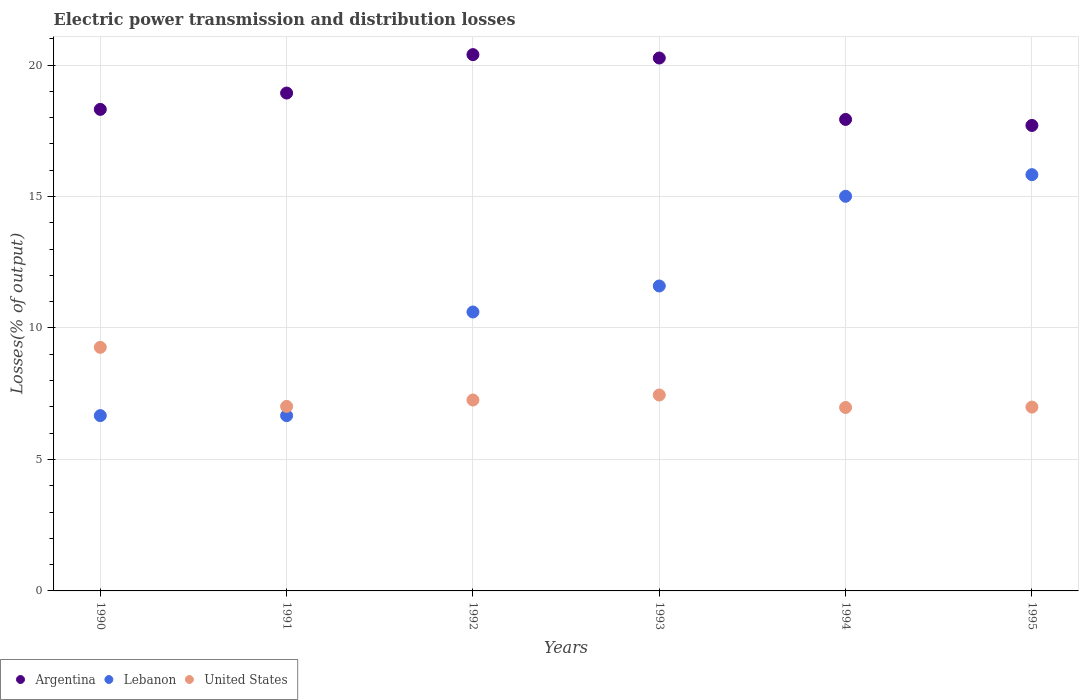How many different coloured dotlines are there?
Your response must be concise. 3. What is the electric power transmission and distribution losses in United States in 1994?
Provide a succinct answer. 6.98. Across all years, what is the maximum electric power transmission and distribution losses in Lebanon?
Give a very brief answer. 15.83. Across all years, what is the minimum electric power transmission and distribution losses in United States?
Provide a short and direct response. 6.98. In which year was the electric power transmission and distribution losses in Argentina maximum?
Provide a succinct answer. 1992. What is the total electric power transmission and distribution losses in Argentina in the graph?
Offer a very short reply. 113.54. What is the difference between the electric power transmission and distribution losses in Lebanon in 1993 and that in 1994?
Your response must be concise. -3.41. What is the difference between the electric power transmission and distribution losses in Argentina in 1992 and the electric power transmission and distribution losses in Lebanon in 1995?
Keep it short and to the point. 4.56. What is the average electric power transmission and distribution losses in Lebanon per year?
Offer a very short reply. 11.06. In the year 1995, what is the difference between the electric power transmission and distribution losses in United States and electric power transmission and distribution losses in Argentina?
Keep it short and to the point. -10.71. In how many years, is the electric power transmission and distribution losses in Argentina greater than 1 %?
Make the answer very short. 6. What is the ratio of the electric power transmission and distribution losses in Lebanon in 1992 to that in 1995?
Your answer should be very brief. 0.67. Is the electric power transmission and distribution losses in Lebanon in 1992 less than that in 1995?
Provide a short and direct response. Yes. What is the difference between the highest and the second highest electric power transmission and distribution losses in United States?
Your response must be concise. 1.81. What is the difference between the highest and the lowest electric power transmission and distribution losses in Lebanon?
Give a very brief answer. 9.16. In how many years, is the electric power transmission and distribution losses in United States greater than the average electric power transmission and distribution losses in United States taken over all years?
Provide a succinct answer. 1. Is the electric power transmission and distribution losses in United States strictly less than the electric power transmission and distribution losses in Lebanon over the years?
Give a very brief answer. No. How many years are there in the graph?
Make the answer very short. 6. Does the graph contain any zero values?
Give a very brief answer. No. Where does the legend appear in the graph?
Ensure brevity in your answer.  Bottom left. How many legend labels are there?
Provide a short and direct response. 3. How are the legend labels stacked?
Your response must be concise. Horizontal. What is the title of the graph?
Your answer should be compact. Electric power transmission and distribution losses. What is the label or title of the Y-axis?
Offer a terse response. Losses(% of output). What is the Losses(% of output) of Argentina in 1990?
Keep it short and to the point. 18.31. What is the Losses(% of output) in Lebanon in 1990?
Provide a short and direct response. 6.67. What is the Losses(% of output) in United States in 1990?
Your answer should be compact. 9.26. What is the Losses(% of output) of Argentina in 1991?
Ensure brevity in your answer.  18.93. What is the Losses(% of output) of Lebanon in 1991?
Provide a succinct answer. 6.67. What is the Losses(% of output) in United States in 1991?
Ensure brevity in your answer.  7.02. What is the Losses(% of output) in Argentina in 1992?
Your response must be concise. 20.4. What is the Losses(% of output) of Lebanon in 1992?
Ensure brevity in your answer.  10.61. What is the Losses(% of output) in United States in 1992?
Offer a terse response. 7.26. What is the Losses(% of output) of Argentina in 1993?
Your answer should be compact. 20.27. What is the Losses(% of output) of Lebanon in 1993?
Offer a terse response. 11.6. What is the Losses(% of output) in United States in 1993?
Provide a short and direct response. 7.45. What is the Losses(% of output) in Argentina in 1994?
Ensure brevity in your answer.  17.93. What is the Losses(% of output) in Lebanon in 1994?
Make the answer very short. 15.01. What is the Losses(% of output) of United States in 1994?
Your response must be concise. 6.98. What is the Losses(% of output) of Argentina in 1995?
Offer a very short reply. 17.7. What is the Losses(% of output) of Lebanon in 1995?
Your answer should be compact. 15.83. What is the Losses(% of output) in United States in 1995?
Your response must be concise. 6.99. Across all years, what is the maximum Losses(% of output) of Argentina?
Give a very brief answer. 20.4. Across all years, what is the maximum Losses(% of output) of Lebanon?
Keep it short and to the point. 15.83. Across all years, what is the maximum Losses(% of output) of United States?
Your response must be concise. 9.26. Across all years, what is the minimum Losses(% of output) in Argentina?
Your answer should be compact. 17.7. Across all years, what is the minimum Losses(% of output) in Lebanon?
Your answer should be very brief. 6.67. Across all years, what is the minimum Losses(% of output) of United States?
Provide a short and direct response. 6.98. What is the total Losses(% of output) in Argentina in the graph?
Provide a succinct answer. 113.54. What is the total Losses(% of output) of Lebanon in the graph?
Your response must be concise. 66.38. What is the total Losses(% of output) in United States in the graph?
Your answer should be compact. 44.96. What is the difference between the Losses(% of output) of Argentina in 1990 and that in 1991?
Provide a short and direct response. -0.62. What is the difference between the Losses(% of output) in Lebanon in 1990 and that in 1991?
Provide a succinct answer. 0. What is the difference between the Losses(% of output) in United States in 1990 and that in 1991?
Your answer should be very brief. 2.25. What is the difference between the Losses(% of output) in Argentina in 1990 and that in 1992?
Offer a very short reply. -2.08. What is the difference between the Losses(% of output) in Lebanon in 1990 and that in 1992?
Provide a short and direct response. -3.94. What is the difference between the Losses(% of output) of United States in 1990 and that in 1992?
Keep it short and to the point. 2. What is the difference between the Losses(% of output) of Argentina in 1990 and that in 1993?
Offer a very short reply. -1.95. What is the difference between the Losses(% of output) of Lebanon in 1990 and that in 1993?
Your answer should be compact. -4.93. What is the difference between the Losses(% of output) in United States in 1990 and that in 1993?
Your answer should be compact. 1.81. What is the difference between the Losses(% of output) of Argentina in 1990 and that in 1994?
Ensure brevity in your answer.  0.38. What is the difference between the Losses(% of output) in Lebanon in 1990 and that in 1994?
Offer a terse response. -8.34. What is the difference between the Losses(% of output) of United States in 1990 and that in 1994?
Ensure brevity in your answer.  2.29. What is the difference between the Losses(% of output) in Argentina in 1990 and that in 1995?
Provide a succinct answer. 0.61. What is the difference between the Losses(% of output) of Lebanon in 1990 and that in 1995?
Make the answer very short. -9.16. What is the difference between the Losses(% of output) of United States in 1990 and that in 1995?
Offer a terse response. 2.27. What is the difference between the Losses(% of output) of Argentina in 1991 and that in 1992?
Ensure brevity in your answer.  -1.46. What is the difference between the Losses(% of output) in Lebanon in 1991 and that in 1992?
Keep it short and to the point. -3.94. What is the difference between the Losses(% of output) in United States in 1991 and that in 1992?
Give a very brief answer. -0.24. What is the difference between the Losses(% of output) of Argentina in 1991 and that in 1993?
Give a very brief answer. -1.33. What is the difference between the Losses(% of output) in Lebanon in 1991 and that in 1993?
Your answer should be compact. -4.93. What is the difference between the Losses(% of output) of United States in 1991 and that in 1993?
Give a very brief answer. -0.43. What is the difference between the Losses(% of output) of Lebanon in 1991 and that in 1994?
Make the answer very short. -8.34. What is the difference between the Losses(% of output) in United States in 1991 and that in 1994?
Your answer should be compact. 0.04. What is the difference between the Losses(% of output) in Argentina in 1991 and that in 1995?
Ensure brevity in your answer.  1.23. What is the difference between the Losses(% of output) of Lebanon in 1991 and that in 1995?
Offer a terse response. -9.16. What is the difference between the Losses(% of output) in United States in 1991 and that in 1995?
Offer a terse response. 0.03. What is the difference between the Losses(% of output) of Argentina in 1992 and that in 1993?
Your answer should be compact. 0.13. What is the difference between the Losses(% of output) of Lebanon in 1992 and that in 1993?
Make the answer very short. -0.99. What is the difference between the Losses(% of output) in United States in 1992 and that in 1993?
Ensure brevity in your answer.  -0.19. What is the difference between the Losses(% of output) in Argentina in 1992 and that in 1994?
Offer a very short reply. 2.46. What is the difference between the Losses(% of output) of Lebanon in 1992 and that in 1994?
Your answer should be very brief. -4.4. What is the difference between the Losses(% of output) of United States in 1992 and that in 1994?
Provide a succinct answer. 0.28. What is the difference between the Losses(% of output) of Argentina in 1992 and that in 1995?
Your response must be concise. 2.69. What is the difference between the Losses(% of output) in Lebanon in 1992 and that in 1995?
Provide a short and direct response. -5.22. What is the difference between the Losses(% of output) of United States in 1992 and that in 1995?
Your answer should be compact. 0.27. What is the difference between the Losses(% of output) in Argentina in 1993 and that in 1994?
Give a very brief answer. 2.34. What is the difference between the Losses(% of output) in Lebanon in 1993 and that in 1994?
Keep it short and to the point. -3.41. What is the difference between the Losses(% of output) in United States in 1993 and that in 1994?
Ensure brevity in your answer.  0.48. What is the difference between the Losses(% of output) of Argentina in 1993 and that in 1995?
Offer a very short reply. 2.56. What is the difference between the Losses(% of output) in Lebanon in 1993 and that in 1995?
Offer a terse response. -4.23. What is the difference between the Losses(% of output) of United States in 1993 and that in 1995?
Your answer should be very brief. 0.46. What is the difference between the Losses(% of output) of Argentina in 1994 and that in 1995?
Provide a short and direct response. 0.23. What is the difference between the Losses(% of output) of Lebanon in 1994 and that in 1995?
Your answer should be compact. -0.82. What is the difference between the Losses(% of output) in United States in 1994 and that in 1995?
Give a very brief answer. -0.01. What is the difference between the Losses(% of output) in Argentina in 1990 and the Losses(% of output) in Lebanon in 1991?
Ensure brevity in your answer.  11.65. What is the difference between the Losses(% of output) in Argentina in 1990 and the Losses(% of output) in United States in 1991?
Provide a succinct answer. 11.3. What is the difference between the Losses(% of output) of Lebanon in 1990 and the Losses(% of output) of United States in 1991?
Give a very brief answer. -0.35. What is the difference between the Losses(% of output) of Argentina in 1990 and the Losses(% of output) of Lebanon in 1992?
Make the answer very short. 7.71. What is the difference between the Losses(% of output) in Argentina in 1990 and the Losses(% of output) in United States in 1992?
Provide a short and direct response. 11.05. What is the difference between the Losses(% of output) of Lebanon in 1990 and the Losses(% of output) of United States in 1992?
Make the answer very short. -0.59. What is the difference between the Losses(% of output) of Argentina in 1990 and the Losses(% of output) of Lebanon in 1993?
Provide a short and direct response. 6.72. What is the difference between the Losses(% of output) in Argentina in 1990 and the Losses(% of output) in United States in 1993?
Your answer should be compact. 10.86. What is the difference between the Losses(% of output) in Lebanon in 1990 and the Losses(% of output) in United States in 1993?
Your answer should be compact. -0.78. What is the difference between the Losses(% of output) of Argentina in 1990 and the Losses(% of output) of Lebanon in 1994?
Your answer should be compact. 3.31. What is the difference between the Losses(% of output) of Argentina in 1990 and the Losses(% of output) of United States in 1994?
Provide a succinct answer. 11.34. What is the difference between the Losses(% of output) of Lebanon in 1990 and the Losses(% of output) of United States in 1994?
Your response must be concise. -0.31. What is the difference between the Losses(% of output) of Argentina in 1990 and the Losses(% of output) of Lebanon in 1995?
Your response must be concise. 2.48. What is the difference between the Losses(% of output) in Argentina in 1990 and the Losses(% of output) in United States in 1995?
Your answer should be very brief. 11.32. What is the difference between the Losses(% of output) of Lebanon in 1990 and the Losses(% of output) of United States in 1995?
Make the answer very short. -0.32. What is the difference between the Losses(% of output) of Argentina in 1991 and the Losses(% of output) of Lebanon in 1992?
Provide a short and direct response. 8.33. What is the difference between the Losses(% of output) in Argentina in 1991 and the Losses(% of output) in United States in 1992?
Your response must be concise. 11.67. What is the difference between the Losses(% of output) of Lebanon in 1991 and the Losses(% of output) of United States in 1992?
Your answer should be very brief. -0.59. What is the difference between the Losses(% of output) in Argentina in 1991 and the Losses(% of output) in Lebanon in 1993?
Make the answer very short. 7.34. What is the difference between the Losses(% of output) of Argentina in 1991 and the Losses(% of output) of United States in 1993?
Keep it short and to the point. 11.48. What is the difference between the Losses(% of output) of Lebanon in 1991 and the Losses(% of output) of United States in 1993?
Keep it short and to the point. -0.78. What is the difference between the Losses(% of output) of Argentina in 1991 and the Losses(% of output) of Lebanon in 1994?
Ensure brevity in your answer.  3.93. What is the difference between the Losses(% of output) of Argentina in 1991 and the Losses(% of output) of United States in 1994?
Ensure brevity in your answer.  11.96. What is the difference between the Losses(% of output) of Lebanon in 1991 and the Losses(% of output) of United States in 1994?
Offer a very short reply. -0.31. What is the difference between the Losses(% of output) of Argentina in 1991 and the Losses(% of output) of Lebanon in 1995?
Provide a short and direct response. 3.1. What is the difference between the Losses(% of output) in Argentina in 1991 and the Losses(% of output) in United States in 1995?
Your response must be concise. 11.94. What is the difference between the Losses(% of output) of Lebanon in 1991 and the Losses(% of output) of United States in 1995?
Ensure brevity in your answer.  -0.32. What is the difference between the Losses(% of output) of Argentina in 1992 and the Losses(% of output) of Lebanon in 1993?
Keep it short and to the point. 8.8. What is the difference between the Losses(% of output) of Argentina in 1992 and the Losses(% of output) of United States in 1993?
Keep it short and to the point. 12.94. What is the difference between the Losses(% of output) of Lebanon in 1992 and the Losses(% of output) of United States in 1993?
Your answer should be compact. 3.16. What is the difference between the Losses(% of output) in Argentina in 1992 and the Losses(% of output) in Lebanon in 1994?
Provide a short and direct response. 5.39. What is the difference between the Losses(% of output) in Argentina in 1992 and the Losses(% of output) in United States in 1994?
Your response must be concise. 13.42. What is the difference between the Losses(% of output) of Lebanon in 1992 and the Losses(% of output) of United States in 1994?
Your response must be concise. 3.63. What is the difference between the Losses(% of output) of Argentina in 1992 and the Losses(% of output) of Lebanon in 1995?
Make the answer very short. 4.56. What is the difference between the Losses(% of output) in Argentina in 1992 and the Losses(% of output) in United States in 1995?
Provide a succinct answer. 13.4. What is the difference between the Losses(% of output) in Lebanon in 1992 and the Losses(% of output) in United States in 1995?
Offer a terse response. 3.62. What is the difference between the Losses(% of output) of Argentina in 1993 and the Losses(% of output) of Lebanon in 1994?
Make the answer very short. 5.26. What is the difference between the Losses(% of output) of Argentina in 1993 and the Losses(% of output) of United States in 1994?
Your answer should be compact. 13.29. What is the difference between the Losses(% of output) of Lebanon in 1993 and the Losses(% of output) of United States in 1994?
Provide a succinct answer. 4.62. What is the difference between the Losses(% of output) of Argentina in 1993 and the Losses(% of output) of Lebanon in 1995?
Offer a terse response. 4.44. What is the difference between the Losses(% of output) of Argentina in 1993 and the Losses(% of output) of United States in 1995?
Offer a very short reply. 13.28. What is the difference between the Losses(% of output) in Lebanon in 1993 and the Losses(% of output) in United States in 1995?
Keep it short and to the point. 4.61. What is the difference between the Losses(% of output) in Argentina in 1994 and the Losses(% of output) in Lebanon in 1995?
Your answer should be very brief. 2.1. What is the difference between the Losses(% of output) of Argentina in 1994 and the Losses(% of output) of United States in 1995?
Provide a short and direct response. 10.94. What is the difference between the Losses(% of output) of Lebanon in 1994 and the Losses(% of output) of United States in 1995?
Offer a terse response. 8.02. What is the average Losses(% of output) in Argentina per year?
Your answer should be compact. 18.92. What is the average Losses(% of output) of Lebanon per year?
Make the answer very short. 11.06. What is the average Losses(% of output) in United States per year?
Ensure brevity in your answer.  7.49. In the year 1990, what is the difference between the Losses(% of output) of Argentina and Losses(% of output) of Lebanon?
Your answer should be compact. 11.65. In the year 1990, what is the difference between the Losses(% of output) in Argentina and Losses(% of output) in United States?
Your answer should be very brief. 9.05. In the year 1990, what is the difference between the Losses(% of output) of Lebanon and Losses(% of output) of United States?
Offer a terse response. -2.6. In the year 1991, what is the difference between the Losses(% of output) in Argentina and Losses(% of output) in Lebanon?
Make the answer very short. 12.27. In the year 1991, what is the difference between the Losses(% of output) of Argentina and Losses(% of output) of United States?
Provide a succinct answer. 11.92. In the year 1991, what is the difference between the Losses(% of output) in Lebanon and Losses(% of output) in United States?
Make the answer very short. -0.35. In the year 1992, what is the difference between the Losses(% of output) of Argentina and Losses(% of output) of Lebanon?
Provide a succinct answer. 9.79. In the year 1992, what is the difference between the Losses(% of output) in Argentina and Losses(% of output) in United States?
Make the answer very short. 13.13. In the year 1992, what is the difference between the Losses(% of output) in Lebanon and Losses(% of output) in United States?
Provide a succinct answer. 3.35. In the year 1993, what is the difference between the Losses(% of output) in Argentina and Losses(% of output) in Lebanon?
Offer a very short reply. 8.67. In the year 1993, what is the difference between the Losses(% of output) of Argentina and Losses(% of output) of United States?
Provide a succinct answer. 12.81. In the year 1993, what is the difference between the Losses(% of output) of Lebanon and Losses(% of output) of United States?
Offer a very short reply. 4.15. In the year 1994, what is the difference between the Losses(% of output) of Argentina and Losses(% of output) of Lebanon?
Offer a very short reply. 2.92. In the year 1994, what is the difference between the Losses(% of output) in Argentina and Losses(% of output) in United States?
Ensure brevity in your answer.  10.95. In the year 1994, what is the difference between the Losses(% of output) of Lebanon and Losses(% of output) of United States?
Your answer should be compact. 8.03. In the year 1995, what is the difference between the Losses(% of output) in Argentina and Losses(% of output) in Lebanon?
Make the answer very short. 1.87. In the year 1995, what is the difference between the Losses(% of output) of Argentina and Losses(% of output) of United States?
Make the answer very short. 10.71. In the year 1995, what is the difference between the Losses(% of output) in Lebanon and Losses(% of output) in United States?
Offer a terse response. 8.84. What is the ratio of the Losses(% of output) of Argentina in 1990 to that in 1991?
Offer a very short reply. 0.97. What is the ratio of the Losses(% of output) of Lebanon in 1990 to that in 1991?
Provide a succinct answer. 1. What is the ratio of the Losses(% of output) of United States in 1990 to that in 1991?
Ensure brevity in your answer.  1.32. What is the ratio of the Losses(% of output) of Argentina in 1990 to that in 1992?
Ensure brevity in your answer.  0.9. What is the ratio of the Losses(% of output) in Lebanon in 1990 to that in 1992?
Offer a terse response. 0.63. What is the ratio of the Losses(% of output) in United States in 1990 to that in 1992?
Your answer should be very brief. 1.28. What is the ratio of the Losses(% of output) in Argentina in 1990 to that in 1993?
Offer a terse response. 0.9. What is the ratio of the Losses(% of output) of Lebanon in 1990 to that in 1993?
Offer a very short reply. 0.57. What is the ratio of the Losses(% of output) in United States in 1990 to that in 1993?
Make the answer very short. 1.24. What is the ratio of the Losses(% of output) of Argentina in 1990 to that in 1994?
Offer a terse response. 1.02. What is the ratio of the Losses(% of output) of Lebanon in 1990 to that in 1994?
Provide a short and direct response. 0.44. What is the ratio of the Losses(% of output) in United States in 1990 to that in 1994?
Provide a succinct answer. 1.33. What is the ratio of the Losses(% of output) of Argentina in 1990 to that in 1995?
Give a very brief answer. 1.03. What is the ratio of the Losses(% of output) in Lebanon in 1990 to that in 1995?
Provide a short and direct response. 0.42. What is the ratio of the Losses(% of output) of United States in 1990 to that in 1995?
Keep it short and to the point. 1.33. What is the ratio of the Losses(% of output) in Argentina in 1991 to that in 1992?
Make the answer very short. 0.93. What is the ratio of the Losses(% of output) of Lebanon in 1991 to that in 1992?
Provide a succinct answer. 0.63. What is the ratio of the Losses(% of output) of United States in 1991 to that in 1992?
Give a very brief answer. 0.97. What is the ratio of the Losses(% of output) of Argentina in 1991 to that in 1993?
Your response must be concise. 0.93. What is the ratio of the Losses(% of output) in Lebanon in 1991 to that in 1993?
Offer a terse response. 0.57. What is the ratio of the Losses(% of output) of United States in 1991 to that in 1993?
Provide a succinct answer. 0.94. What is the ratio of the Losses(% of output) in Argentina in 1991 to that in 1994?
Offer a terse response. 1.06. What is the ratio of the Losses(% of output) in Lebanon in 1991 to that in 1994?
Your answer should be compact. 0.44. What is the ratio of the Losses(% of output) in United States in 1991 to that in 1994?
Give a very brief answer. 1.01. What is the ratio of the Losses(% of output) of Argentina in 1991 to that in 1995?
Keep it short and to the point. 1.07. What is the ratio of the Losses(% of output) in Lebanon in 1991 to that in 1995?
Provide a succinct answer. 0.42. What is the ratio of the Losses(% of output) of Argentina in 1992 to that in 1993?
Your answer should be very brief. 1.01. What is the ratio of the Losses(% of output) in Lebanon in 1992 to that in 1993?
Ensure brevity in your answer.  0.91. What is the ratio of the Losses(% of output) of United States in 1992 to that in 1993?
Offer a very short reply. 0.97. What is the ratio of the Losses(% of output) of Argentina in 1992 to that in 1994?
Provide a short and direct response. 1.14. What is the ratio of the Losses(% of output) of Lebanon in 1992 to that in 1994?
Keep it short and to the point. 0.71. What is the ratio of the Losses(% of output) of United States in 1992 to that in 1994?
Offer a terse response. 1.04. What is the ratio of the Losses(% of output) in Argentina in 1992 to that in 1995?
Your answer should be compact. 1.15. What is the ratio of the Losses(% of output) in Lebanon in 1992 to that in 1995?
Keep it short and to the point. 0.67. What is the ratio of the Losses(% of output) in United States in 1992 to that in 1995?
Your answer should be compact. 1.04. What is the ratio of the Losses(% of output) in Argentina in 1993 to that in 1994?
Provide a short and direct response. 1.13. What is the ratio of the Losses(% of output) in Lebanon in 1993 to that in 1994?
Your answer should be compact. 0.77. What is the ratio of the Losses(% of output) in United States in 1993 to that in 1994?
Your answer should be compact. 1.07. What is the ratio of the Losses(% of output) of Argentina in 1993 to that in 1995?
Provide a short and direct response. 1.14. What is the ratio of the Losses(% of output) in Lebanon in 1993 to that in 1995?
Make the answer very short. 0.73. What is the ratio of the Losses(% of output) in United States in 1993 to that in 1995?
Your response must be concise. 1.07. What is the ratio of the Losses(% of output) in Argentina in 1994 to that in 1995?
Offer a very short reply. 1.01. What is the ratio of the Losses(% of output) of Lebanon in 1994 to that in 1995?
Offer a very short reply. 0.95. What is the difference between the highest and the second highest Losses(% of output) in Argentina?
Offer a very short reply. 0.13. What is the difference between the highest and the second highest Losses(% of output) of Lebanon?
Offer a very short reply. 0.82. What is the difference between the highest and the second highest Losses(% of output) of United States?
Offer a terse response. 1.81. What is the difference between the highest and the lowest Losses(% of output) in Argentina?
Offer a very short reply. 2.69. What is the difference between the highest and the lowest Losses(% of output) in Lebanon?
Make the answer very short. 9.16. What is the difference between the highest and the lowest Losses(% of output) in United States?
Provide a short and direct response. 2.29. 